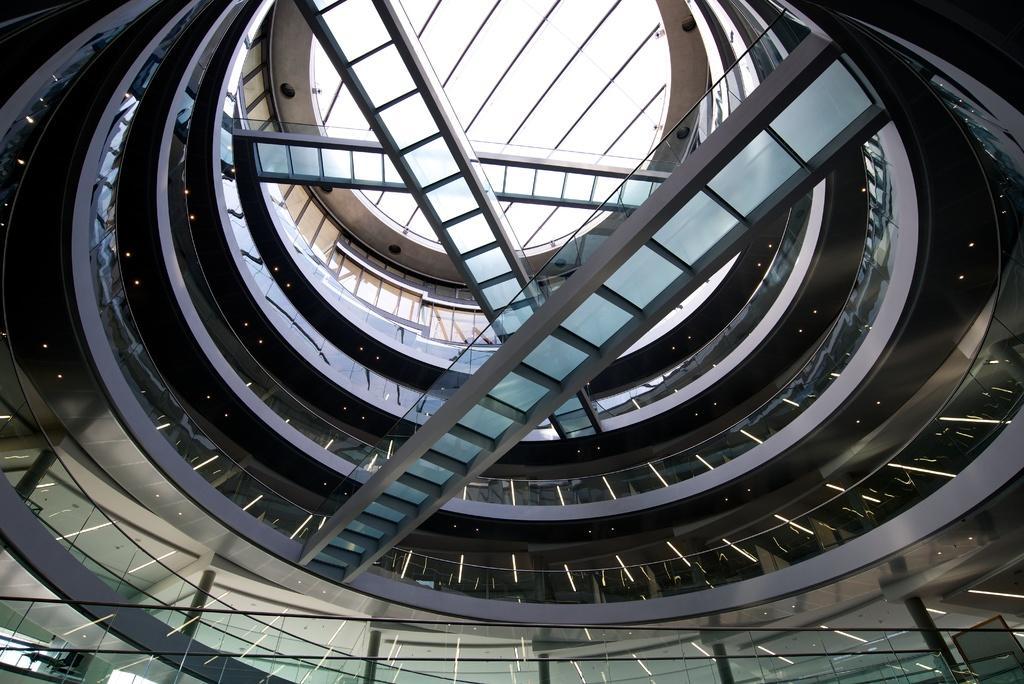Could you give a brief overview of what you see in this image? In this image I can see the interior of the building. I can see the floors of the buildings, few bridges, the glass railing, number of lights, the white colored ceiling and few windows to the left bottom of the image. 